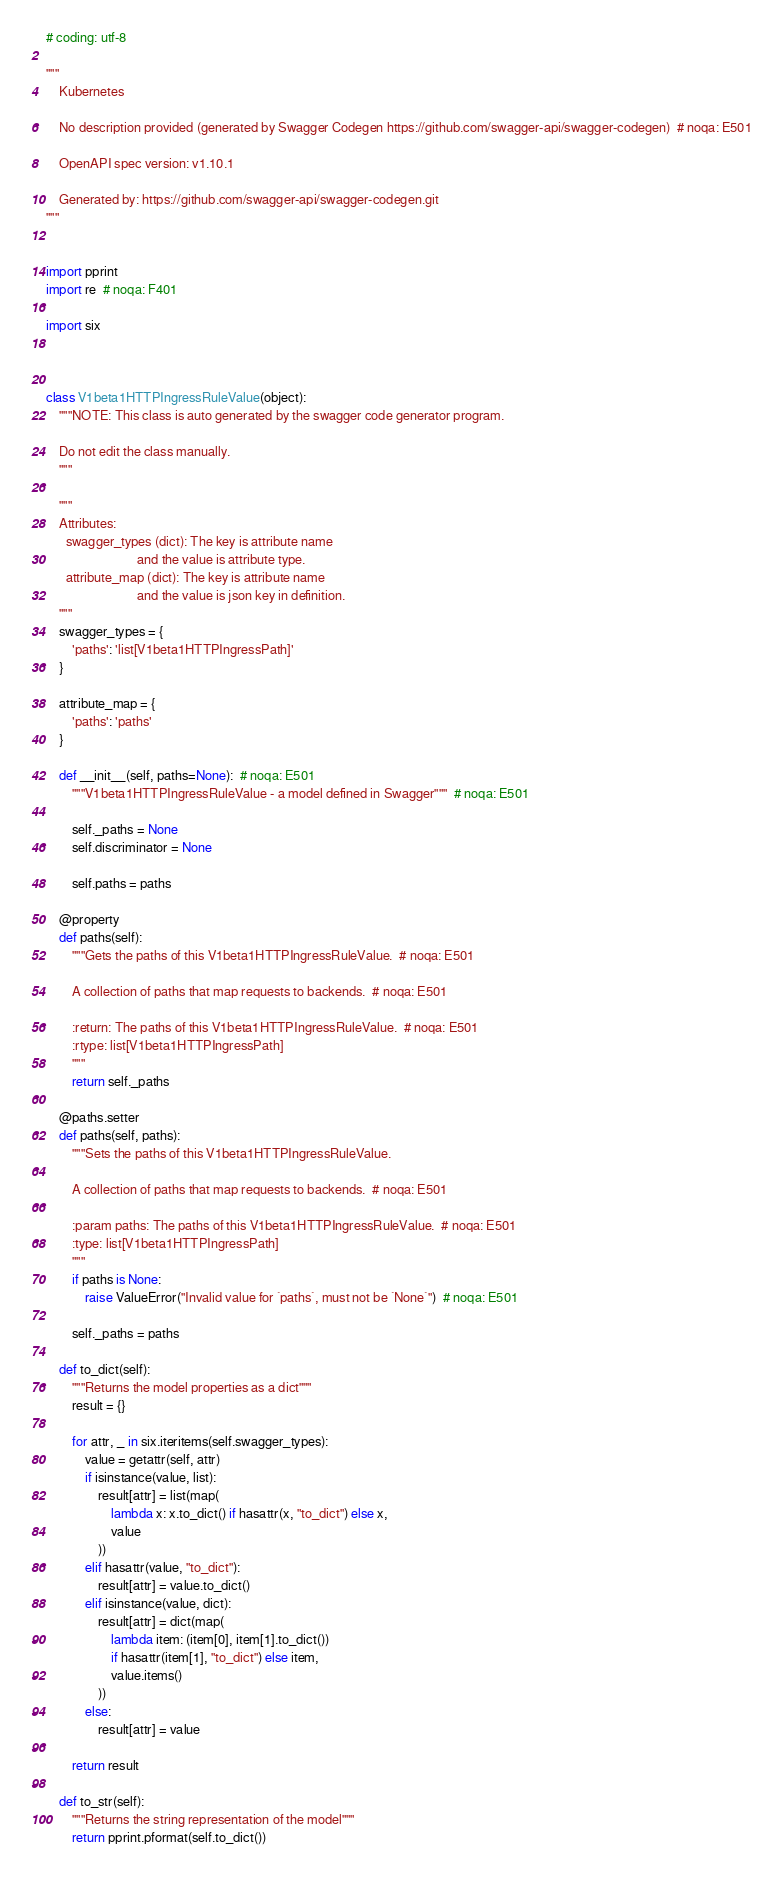<code> <loc_0><loc_0><loc_500><loc_500><_Python_># coding: utf-8

"""
    Kubernetes

    No description provided (generated by Swagger Codegen https://github.com/swagger-api/swagger-codegen)  # noqa: E501

    OpenAPI spec version: v1.10.1
    
    Generated by: https://github.com/swagger-api/swagger-codegen.git
"""


import pprint
import re  # noqa: F401

import six



class V1beta1HTTPIngressRuleValue(object):
    """NOTE: This class is auto generated by the swagger code generator program.

    Do not edit the class manually.
    """

    """
    Attributes:
      swagger_types (dict): The key is attribute name
                            and the value is attribute type.
      attribute_map (dict): The key is attribute name
                            and the value is json key in definition.
    """
    swagger_types = {
        'paths': 'list[V1beta1HTTPIngressPath]'
    }

    attribute_map = {
        'paths': 'paths'
    }

    def __init__(self, paths=None):  # noqa: E501
        """V1beta1HTTPIngressRuleValue - a model defined in Swagger"""  # noqa: E501

        self._paths = None
        self.discriminator = None

        self.paths = paths

    @property
    def paths(self):
        """Gets the paths of this V1beta1HTTPIngressRuleValue.  # noqa: E501

        A collection of paths that map requests to backends.  # noqa: E501

        :return: The paths of this V1beta1HTTPIngressRuleValue.  # noqa: E501
        :rtype: list[V1beta1HTTPIngressPath]
        """
        return self._paths

    @paths.setter
    def paths(self, paths):
        """Sets the paths of this V1beta1HTTPIngressRuleValue.

        A collection of paths that map requests to backends.  # noqa: E501

        :param paths: The paths of this V1beta1HTTPIngressRuleValue.  # noqa: E501
        :type: list[V1beta1HTTPIngressPath]
        """
        if paths is None:
            raise ValueError("Invalid value for `paths`, must not be `None`")  # noqa: E501

        self._paths = paths

    def to_dict(self):
        """Returns the model properties as a dict"""
        result = {}

        for attr, _ in six.iteritems(self.swagger_types):
            value = getattr(self, attr)
            if isinstance(value, list):
                result[attr] = list(map(
                    lambda x: x.to_dict() if hasattr(x, "to_dict") else x,
                    value
                ))
            elif hasattr(value, "to_dict"):
                result[attr] = value.to_dict()
            elif isinstance(value, dict):
                result[attr] = dict(map(
                    lambda item: (item[0], item[1].to_dict())
                    if hasattr(item[1], "to_dict") else item,
                    value.items()
                ))
            else:
                result[attr] = value

        return result

    def to_str(self):
        """Returns the string representation of the model"""
        return pprint.pformat(self.to_dict())
</code> 